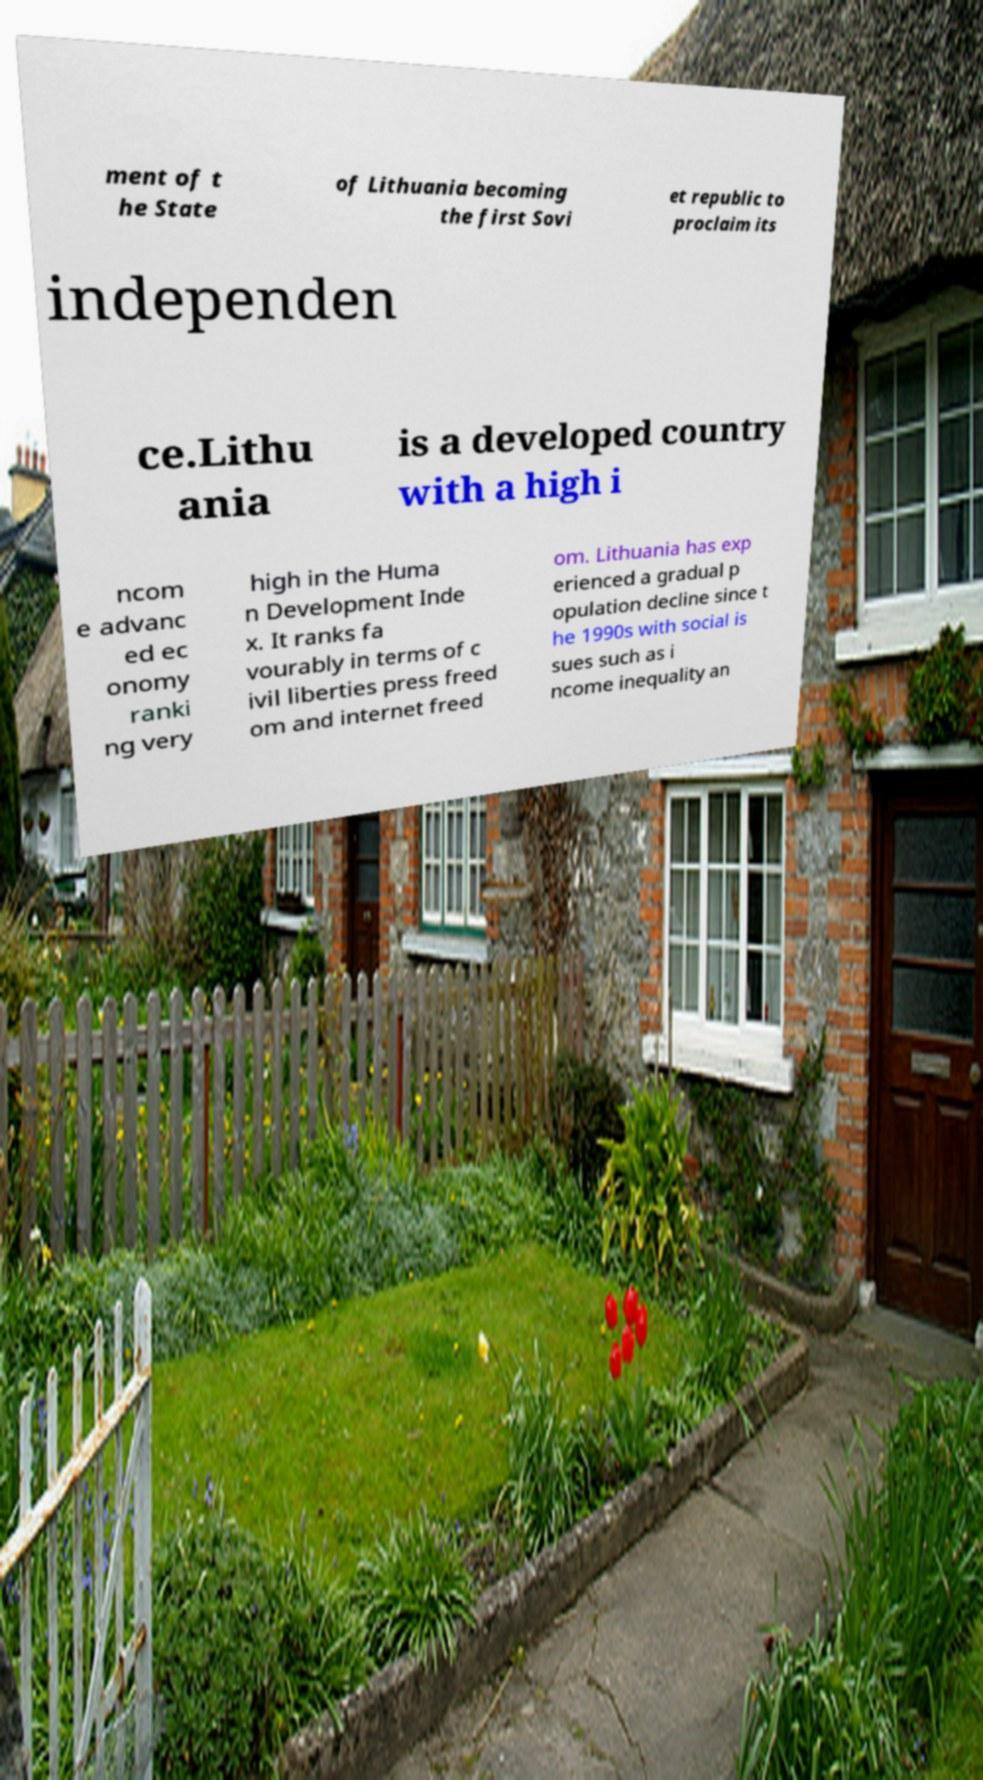Please read and relay the text visible in this image. What does it say? ment of t he State of Lithuania becoming the first Sovi et republic to proclaim its independen ce.Lithu ania is a developed country with a high i ncom e advanc ed ec onomy ranki ng very high in the Huma n Development Inde x. It ranks fa vourably in terms of c ivil liberties press freed om and internet freed om. Lithuania has exp erienced a gradual p opulation decline since t he 1990s with social is sues such as i ncome inequality an 